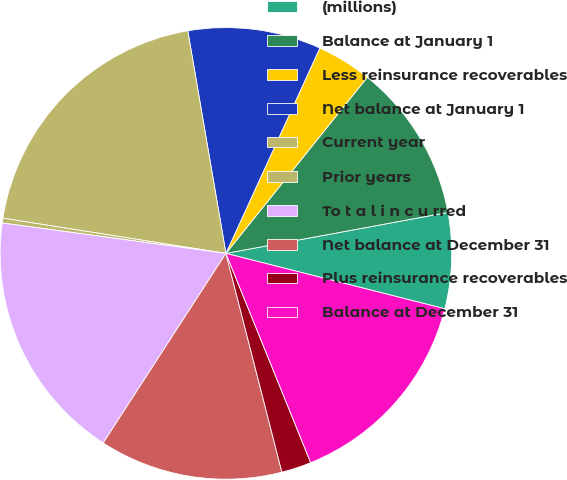<chart> <loc_0><loc_0><loc_500><loc_500><pie_chart><fcel>(millions)<fcel>Balance at January 1<fcel>Less reinsurance recoverables<fcel>Net balance at January 1<fcel>Current year<fcel>Prior years<fcel>To t a l i n c u rred<fcel>Net balance at December 31<fcel>Plus reinsurance recoverables<fcel>Balance at December 31<nl><fcel>6.85%<fcel>11.33%<fcel>3.94%<fcel>9.53%<fcel>19.81%<fcel>0.34%<fcel>18.01%<fcel>13.13%<fcel>2.14%<fcel>14.93%<nl></chart> 